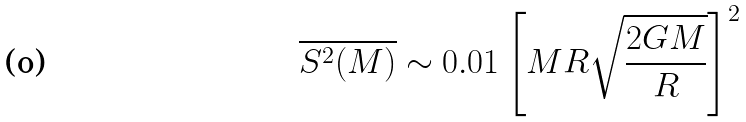<formula> <loc_0><loc_0><loc_500><loc_500>\overline { S ^ { 2 } ( M ) } \sim 0 . 0 1 \left [ M R \sqrt { \frac { 2 G M } { R } } \right ] ^ { 2 }</formula> 